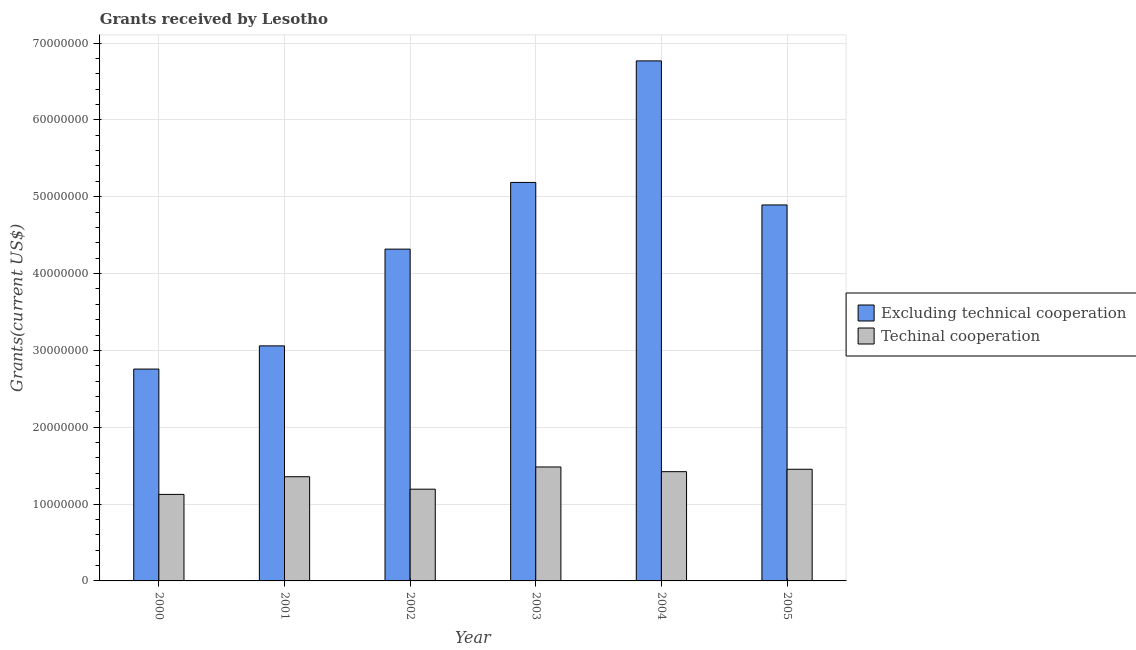How many different coloured bars are there?
Give a very brief answer. 2. Are the number of bars per tick equal to the number of legend labels?
Offer a very short reply. Yes. In how many cases, is the number of bars for a given year not equal to the number of legend labels?
Keep it short and to the point. 0. What is the amount of grants received(including technical cooperation) in 2002?
Offer a very short reply. 1.19e+07. Across all years, what is the maximum amount of grants received(including technical cooperation)?
Ensure brevity in your answer.  1.48e+07. Across all years, what is the minimum amount of grants received(including technical cooperation)?
Your response must be concise. 1.13e+07. In which year was the amount of grants received(including technical cooperation) maximum?
Your answer should be very brief. 2003. What is the total amount of grants received(excluding technical cooperation) in the graph?
Your answer should be compact. 2.70e+08. What is the difference between the amount of grants received(excluding technical cooperation) in 2000 and that in 2004?
Make the answer very short. -4.01e+07. What is the difference between the amount of grants received(excluding technical cooperation) in 2001 and the amount of grants received(including technical cooperation) in 2000?
Give a very brief answer. 3.02e+06. What is the average amount of grants received(excluding technical cooperation) per year?
Ensure brevity in your answer.  4.50e+07. In the year 2003, what is the difference between the amount of grants received(including technical cooperation) and amount of grants received(excluding technical cooperation)?
Ensure brevity in your answer.  0. In how many years, is the amount of grants received(excluding technical cooperation) greater than 6000000 US$?
Offer a very short reply. 6. What is the ratio of the amount of grants received(including technical cooperation) in 2001 to that in 2002?
Ensure brevity in your answer.  1.14. Is the amount of grants received(including technical cooperation) in 2001 less than that in 2003?
Provide a succinct answer. Yes. Is the difference between the amount of grants received(including technical cooperation) in 2002 and 2003 greater than the difference between the amount of grants received(excluding technical cooperation) in 2002 and 2003?
Keep it short and to the point. No. What is the difference between the highest and the lowest amount of grants received(including technical cooperation)?
Offer a terse response. 3.57e+06. In how many years, is the amount of grants received(including technical cooperation) greater than the average amount of grants received(including technical cooperation) taken over all years?
Make the answer very short. 4. Is the sum of the amount of grants received(excluding technical cooperation) in 2001 and 2004 greater than the maximum amount of grants received(including technical cooperation) across all years?
Ensure brevity in your answer.  Yes. What does the 1st bar from the left in 2000 represents?
Offer a terse response. Excluding technical cooperation. What does the 2nd bar from the right in 2003 represents?
Provide a succinct answer. Excluding technical cooperation. How many years are there in the graph?
Keep it short and to the point. 6. Does the graph contain any zero values?
Offer a very short reply. No. Does the graph contain grids?
Make the answer very short. Yes. How many legend labels are there?
Offer a very short reply. 2. What is the title of the graph?
Offer a terse response. Grants received by Lesotho. What is the label or title of the Y-axis?
Keep it short and to the point. Grants(current US$). What is the Grants(current US$) of Excluding technical cooperation in 2000?
Give a very brief answer. 2.76e+07. What is the Grants(current US$) in Techinal cooperation in 2000?
Provide a succinct answer. 1.13e+07. What is the Grants(current US$) in Excluding technical cooperation in 2001?
Provide a short and direct response. 3.06e+07. What is the Grants(current US$) in Techinal cooperation in 2001?
Offer a very short reply. 1.36e+07. What is the Grants(current US$) of Excluding technical cooperation in 2002?
Give a very brief answer. 4.32e+07. What is the Grants(current US$) in Techinal cooperation in 2002?
Offer a terse response. 1.19e+07. What is the Grants(current US$) in Excluding technical cooperation in 2003?
Provide a succinct answer. 5.19e+07. What is the Grants(current US$) in Techinal cooperation in 2003?
Your answer should be compact. 1.48e+07. What is the Grants(current US$) of Excluding technical cooperation in 2004?
Your answer should be very brief. 6.77e+07. What is the Grants(current US$) of Techinal cooperation in 2004?
Your answer should be compact. 1.42e+07. What is the Grants(current US$) of Excluding technical cooperation in 2005?
Ensure brevity in your answer.  4.89e+07. What is the Grants(current US$) in Techinal cooperation in 2005?
Ensure brevity in your answer.  1.45e+07. Across all years, what is the maximum Grants(current US$) of Excluding technical cooperation?
Your answer should be compact. 6.77e+07. Across all years, what is the maximum Grants(current US$) in Techinal cooperation?
Ensure brevity in your answer.  1.48e+07. Across all years, what is the minimum Grants(current US$) of Excluding technical cooperation?
Your answer should be compact. 2.76e+07. Across all years, what is the minimum Grants(current US$) of Techinal cooperation?
Offer a very short reply. 1.13e+07. What is the total Grants(current US$) in Excluding technical cooperation in the graph?
Make the answer very short. 2.70e+08. What is the total Grants(current US$) in Techinal cooperation in the graph?
Offer a very short reply. 8.03e+07. What is the difference between the Grants(current US$) of Excluding technical cooperation in 2000 and that in 2001?
Give a very brief answer. -3.02e+06. What is the difference between the Grants(current US$) of Techinal cooperation in 2000 and that in 2001?
Your response must be concise. -2.30e+06. What is the difference between the Grants(current US$) of Excluding technical cooperation in 2000 and that in 2002?
Your answer should be compact. -1.56e+07. What is the difference between the Grants(current US$) in Techinal cooperation in 2000 and that in 2002?
Provide a short and direct response. -6.80e+05. What is the difference between the Grants(current US$) in Excluding technical cooperation in 2000 and that in 2003?
Your response must be concise. -2.43e+07. What is the difference between the Grants(current US$) of Techinal cooperation in 2000 and that in 2003?
Make the answer very short. -3.57e+06. What is the difference between the Grants(current US$) in Excluding technical cooperation in 2000 and that in 2004?
Your answer should be very brief. -4.01e+07. What is the difference between the Grants(current US$) of Techinal cooperation in 2000 and that in 2004?
Ensure brevity in your answer.  -2.96e+06. What is the difference between the Grants(current US$) of Excluding technical cooperation in 2000 and that in 2005?
Make the answer very short. -2.14e+07. What is the difference between the Grants(current US$) in Techinal cooperation in 2000 and that in 2005?
Provide a short and direct response. -3.27e+06. What is the difference between the Grants(current US$) in Excluding technical cooperation in 2001 and that in 2002?
Your answer should be compact. -1.26e+07. What is the difference between the Grants(current US$) of Techinal cooperation in 2001 and that in 2002?
Provide a short and direct response. 1.62e+06. What is the difference between the Grants(current US$) in Excluding technical cooperation in 2001 and that in 2003?
Offer a very short reply. -2.13e+07. What is the difference between the Grants(current US$) in Techinal cooperation in 2001 and that in 2003?
Offer a terse response. -1.27e+06. What is the difference between the Grants(current US$) in Excluding technical cooperation in 2001 and that in 2004?
Offer a very short reply. -3.71e+07. What is the difference between the Grants(current US$) in Techinal cooperation in 2001 and that in 2004?
Offer a terse response. -6.60e+05. What is the difference between the Grants(current US$) in Excluding technical cooperation in 2001 and that in 2005?
Give a very brief answer. -1.83e+07. What is the difference between the Grants(current US$) of Techinal cooperation in 2001 and that in 2005?
Ensure brevity in your answer.  -9.70e+05. What is the difference between the Grants(current US$) of Excluding technical cooperation in 2002 and that in 2003?
Offer a terse response. -8.68e+06. What is the difference between the Grants(current US$) of Techinal cooperation in 2002 and that in 2003?
Keep it short and to the point. -2.89e+06. What is the difference between the Grants(current US$) of Excluding technical cooperation in 2002 and that in 2004?
Make the answer very short. -2.45e+07. What is the difference between the Grants(current US$) of Techinal cooperation in 2002 and that in 2004?
Your answer should be very brief. -2.28e+06. What is the difference between the Grants(current US$) of Excluding technical cooperation in 2002 and that in 2005?
Provide a short and direct response. -5.75e+06. What is the difference between the Grants(current US$) of Techinal cooperation in 2002 and that in 2005?
Your response must be concise. -2.59e+06. What is the difference between the Grants(current US$) of Excluding technical cooperation in 2003 and that in 2004?
Provide a succinct answer. -1.58e+07. What is the difference between the Grants(current US$) of Techinal cooperation in 2003 and that in 2004?
Ensure brevity in your answer.  6.10e+05. What is the difference between the Grants(current US$) of Excluding technical cooperation in 2003 and that in 2005?
Offer a very short reply. 2.93e+06. What is the difference between the Grants(current US$) in Techinal cooperation in 2003 and that in 2005?
Offer a terse response. 3.00e+05. What is the difference between the Grants(current US$) in Excluding technical cooperation in 2004 and that in 2005?
Offer a very short reply. 1.88e+07. What is the difference between the Grants(current US$) of Techinal cooperation in 2004 and that in 2005?
Provide a succinct answer. -3.10e+05. What is the difference between the Grants(current US$) in Excluding technical cooperation in 2000 and the Grants(current US$) in Techinal cooperation in 2001?
Provide a succinct answer. 1.40e+07. What is the difference between the Grants(current US$) of Excluding technical cooperation in 2000 and the Grants(current US$) of Techinal cooperation in 2002?
Your answer should be very brief. 1.56e+07. What is the difference between the Grants(current US$) in Excluding technical cooperation in 2000 and the Grants(current US$) in Techinal cooperation in 2003?
Offer a terse response. 1.27e+07. What is the difference between the Grants(current US$) in Excluding technical cooperation in 2000 and the Grants(current US$) in Techinal cooperation in 2004?
Ensure brevity in your answer.  1.34e+07. What is the difference between the Grants(current US$) in Excluding technical cooperation in 2000 and the Grants(current US$) in Techinal cooperation in 2005?
Offer a terse response. 1.30e+07. What is the difference between the Grants(current US$) in Excluding technical cooperation in 2001 and the Grants(current US$) in Techinal cooperation in 2002?
Make the answer very short. 1.86e+07. What is the difference between the Grants(current US$) of Excluding technical cooperation in 2001 and the Grants(current US$) of Techinal cooperation in 2003?
Your response must be concise. 1.58e+07. What is the difference between the Grants(current US$) of Excluding technical cooperation in 2001 and the Grants(current US$) of Techinal cooperation in 2004?
Provide a short and direct response. 1.64e+07. What is the difference between the Grants(current US$) of Excluding technical cooperation in 2001 and the Grants(current US$) of Techinal cooperation in 2005?
Your response must be concise. 1.61e+07. What is the difference between the Grants(current US$) in Excluding technical cooperation in 2002 and the Grants(current US$) in Techinal cooperation in 2003?
Offer a very short reply. 2.84e+07. What is the difference between the Grants(current US$) of Excluding technical cooperation in 2002 and the Grants(current US$) of Techinal cooperation in 2004?
Your answer should be very brief. 2.90e+07. What is the difference between the Grants(current US$) in Excluding technical cooperation in 2002 and the Grants(current US$) in Techinal cooperation in 2005?
Your response must be concise. 2.86e+07. What is the difference between the Grants(current US$) in Excluding technical cooperation in 2003 and the Grants(current US$) in Techinal cooperation in 2004?
Ensure brevity in your answer.  3.76e+07. What is the difference between the Grants(current US$) in Excluding technical cooperation in 2003 and the Grants(current US$) in Techinal cooperation in 2005?
Provide a short and direct response. 3.73e+07. What is the difference between the Grants(current US$) in Excluding technical cooperation in 2004 and the Grants(current US$) in Techinal cooperation in 2005?
Give a very brief answer. 5.32e+07. What is the average Grants(current US$) in Excluding technical cooperation per year?
Ensure brevity in your answer.  4.50e+07. What is the average Grants(current US$) of Techinal cooperation per year?
Your response must be concise. 1.34e+07. In the year 2000, what is the difference between the Grants(current US$) in Excluding technical cooperation and Grants(current US$) in Techinal cooperation?
Your answer should be compact. 1.63e+07. In the year 2001, what is the difference between the Grants(current US$) of Excluding technical cooperation and Grants(current US$) of Techinal cooperation?
Your answer should be compact. 1.70e+07. In the year 2002, what is the difference between the Grants(current US$) of Excluding technical cooperation and Grants(current US$) of Techinal cooperation?
Keep it short and to the point. 3.12e+07. In the year 2003, what is the difference between the Grants(current US$) of Excluding technical cooperation and Grants(current US$) of Techinal cooperation?
Make the answer very short. 3.70e+07. In the year 2004, what is the difference between the Grants(current US$) in Excluding technical cooperation and Grants(current US$) in Techinal cooperation?
Your answer should be compact. 5.35e+07. In the year 2005, what is the difference between the Grants(current US$) of Excluding technical cooperation and Grants(current US$) of Techinal cooperation?
Keep it short and to the point. 3.44e+07. What is the ratio of the Grants(current US$) in Excluding technical cooperation in 2000 to that in 2001?
Give a very brief answer. 0.9. What is the ratio of the Grants(current US$) in Techinal cooperation in 2000 to that in 2001?
Offer a terse response. 0.83. What is the ratio of the Grants(current US$) in Excluding technical cooperation in 2000 to that in 2002?
Your answer should be very brief. 0.64. What is the ratio of the Grants(current US$) in Techinal cooperation in 2000 to that in 2002?
Your answer should be compact. 0.94. What is the ratio of the Grants(current US$) in Excluding technical cooperation in 2000 to that in 2003?
Ensure brevity in your answer.  0.53. What is the ratio of the Grants(current US$) in Techinal cooperation in 2000 to that in 2003?
Ensure brevity in your answer.  0.76. What is the ratio of the Grants(current US$) in Excluding technical cooperation in 2000 to that in 2004?
Ensure brevity in your answer.  0.41. What is the ratio of the Grants(current US$) of Techinal cooperation in 2000 to that in 2004?
Keep it short and to the point. 0.79. What is the ratio of the Grants(current US$) of Excluding technical cooperation in 2000 to that in 2005?
Your response must be concise. 0.56. What is the ratio of the Grants(current US$) in Techinal cooperation in 2000 to that in 2005?
Your answer should be very brief. 0.77. What is the ratio of the Grants(current US$) in Excluding technical cooperation in 2001 to that in 2002?
Your answer should be compact. 0.71. What is the ratio of the Grants(current US$) of Techinal cooperation in 2001 to that in 2002?
Offer a very short reply. 1.14. What is the ratio of the Grants(current US$) in Excluding technical cooperation in 2001 to that in 2003?
Your answer should be compact. 0.59. What is the ratio of the Grants(current US$) of Techinal cooperation in 2001 to that in 2003?
Make the answer very short. 0.91. What is the ratio of the Grants(current US$) of Excluding technical cooperation in 2001 to that in 2004?
Keep it short and to the point. 0.45. What is the ratio of the Grants(current US$) of Techinal cooperation in 2001 to that in 2004?
Provide a succinct answer. 0.95. What is the ratio of the Grants(current US$) of Excluding technical cooperation in 2001 to that in 2005?
Your answer should be very brief. 0.63. What is the ratio of the Grants(current US$) of Techinal cooperation in 2001 to that in 2005?
Offer a terse response. 0.93. What is the ratio of the Grants(current US$) in Excluding technical cooperation in 2002 to that in 2003?
Your answer should be compact. 0.83. What is the ratio of the Grants(current US$) in Techinal cooperation in 2002 to that in 2003?
Give a very brief answer. 0.81. What is the ratio of the Grants(current US$) of Excluding technical cooperation in 2002 to that in 2004?
Your answer should be very brief. 0.64. What is the ratio of the Grants(current US$) in Techinal cooperation in 2002 to that in 2004?
Your answer should be compact. 0.84. What is the ratio of the Grants(current US$) of Excluding technical cooperation in 2002 to that in 2005?
Ensure brevity in your answer.  0.88. What is the ratio of the Grants(current US$) in Techinal cooperation in 2002 to that in 2005?
Offer a very short reply. 0.82. What is the ratio of the Grants(current US$) of Excluding technical cooperation in 2003 to that in 2004?
Offer a terse response. 0.77. What is the ratio of the Grants(current US$) in Techinal cooperation in 2003 to that in 2004?
Keep it short and to the point. 1.04. What is the ratio of the Grants(current US$) in Excluding technical cooperation in 2003 to that in 2005?
Offer a terse response. 1.06. What is the ratio of the Grants(current US$) in Techinal cooperation in 2003 to that in 2005?
Your answer should be compact. 1.02. What is the ratio of the Grants(current US$) of Excluding technical cooperation in 2004 to that in 2005?
Your response must be concise. 1.38. What is the ratio of the Grants(current US$) of Techinal cooperation in 2004 to that in 2005?
Provide a succinct answer. 0.98. What is the difference between the highest and the second highest Grants(current US$) in Excluding technical cooperation?
Provide a short and direct response. 1.58e+07. What is the difference between the highest and the second highest Grants(current US$) of Techinal cooperation?
Your answer should be compact. 3.00e+05. What is the difference between the highest and the lowest Grants(current US$) of Excluding technical cooperation?
Keep it short and to the point. 4.01e+07. What is the difference between the highest and the lowest Grants(current US$) of Techinal cooperation?
Ensure brevity in your answer.  3.57e+06. 